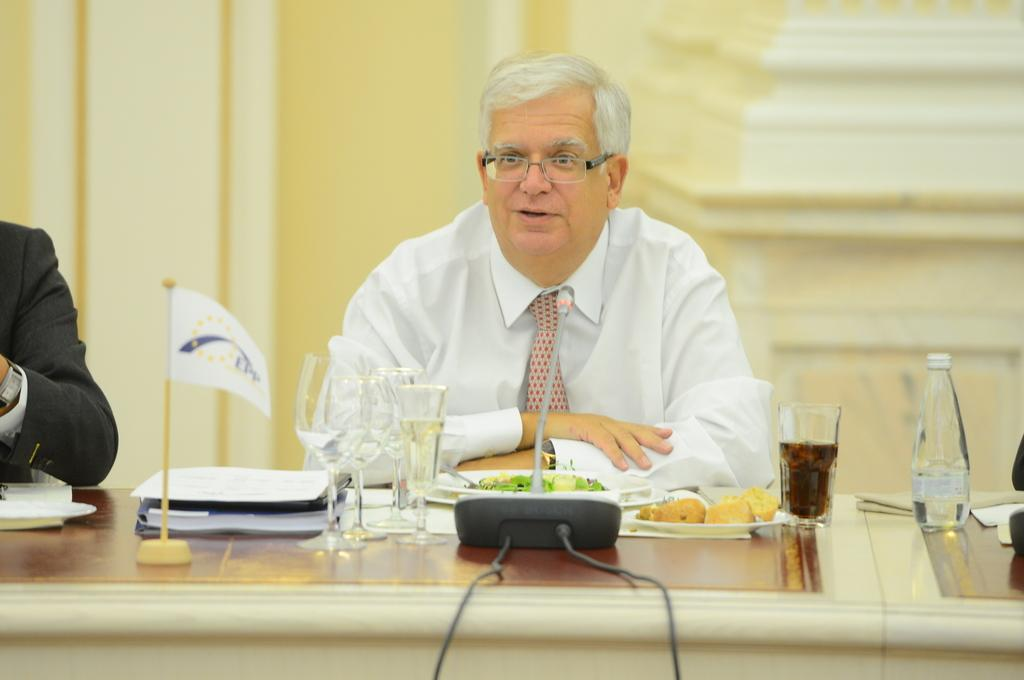What is the person in the image wearing? The person is wearing a white shirt in the image. What is the person doing in the image? The person is sitting on a table. What else can be seen on the table besides the person? Food items, a mic, and a flag are present on the table. What color is the background of the image? The background of the image is a yellow wall. What type of nerve can be seen in the image? There is no nerve present in the image; it features a person sitting on a table with various items on it. How does the kitty feel about the person sitting on the table? There is no kitty present in the image, so it is not possible to determine how a kitty might feel about the person sitting on the table. 